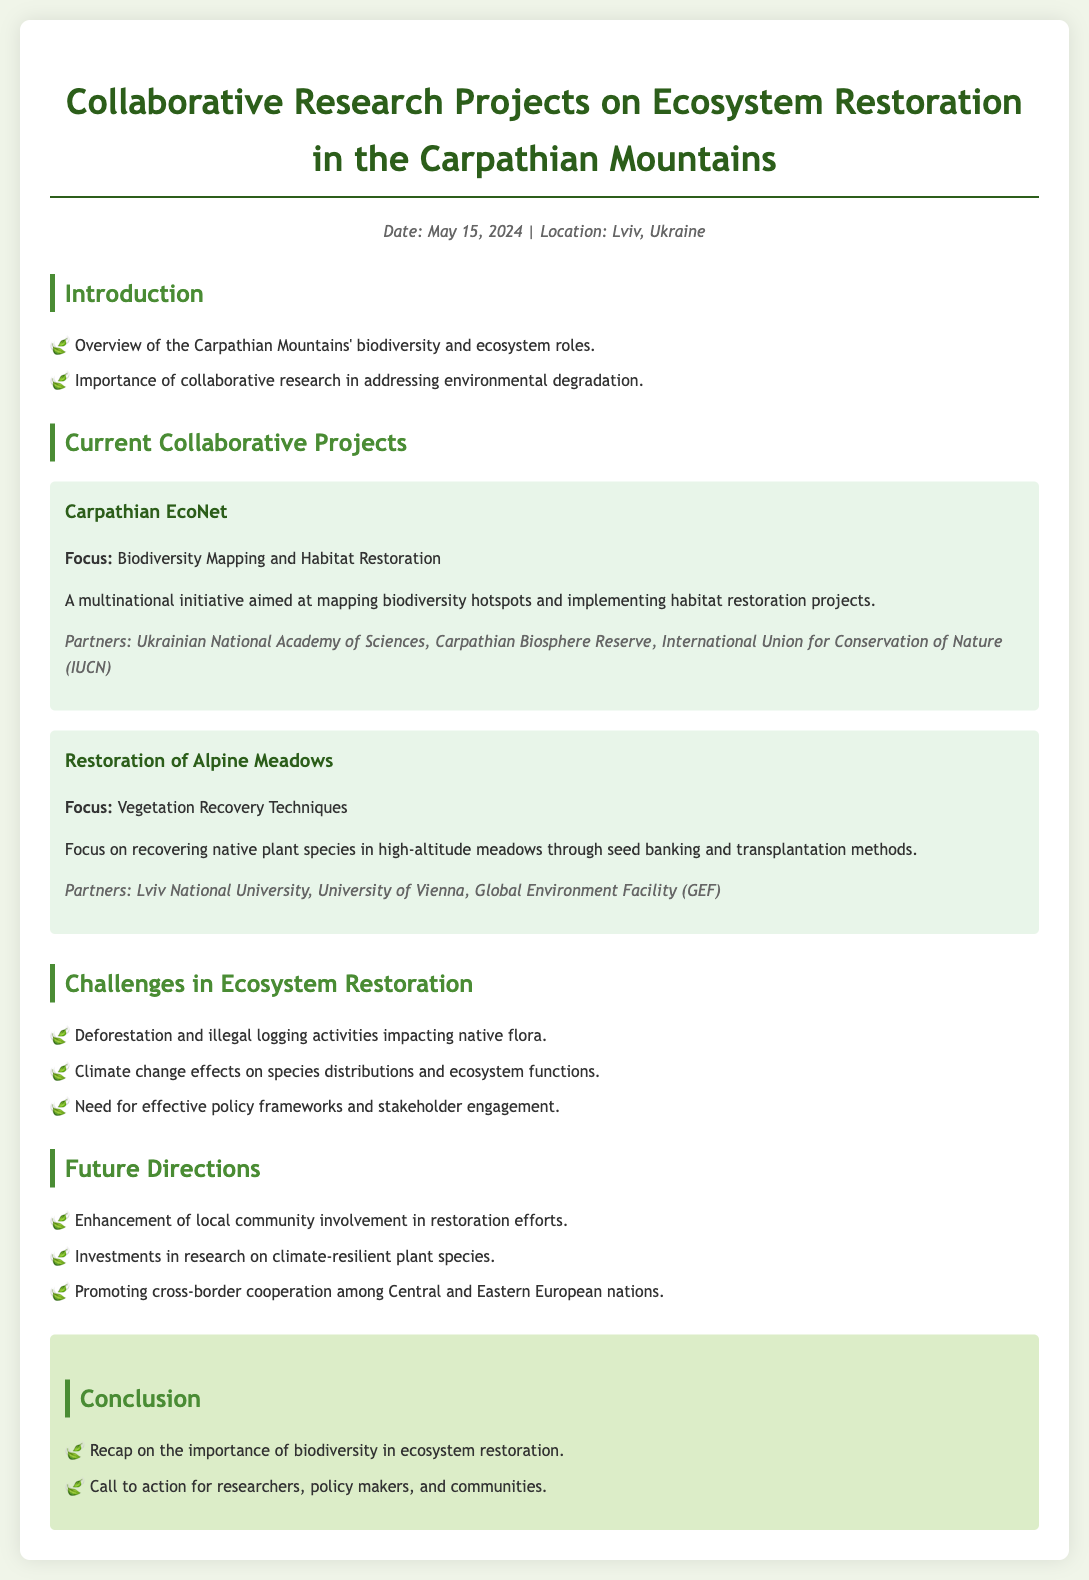What date is the agenda dated? The agenda is dated May 15, 2024, as stated at the top of the document.
Answer: May 15, 2024 What is the focus of the Carpathian EcoNet project? The project focuses on biodiversity mapping and habitat restoration, as mentioned in the document.
Answer: Biodiversity Mapping and Habitat Restoration Who are the partners of the Restoration of Alpine Meadows project? The document lists Lviv National University, University of Vienna, and Global Environment Facility (GEF) as partners.
Answer: Lviv National University, University of Vienna, Global Environment Facility (GEF) What is a major challenge in ecosystem restoration mentioned in the document? The document states that deforestation and illegal logging activities are major challenges affecting native flora.
Answer: Deforestation and illegal logging What is one future direction for ecosystem restoration mentioned? The document highlights the enhancement of local community involvement in restoration efforts as a future direction.
Answer: Enhancement of local community involvement 